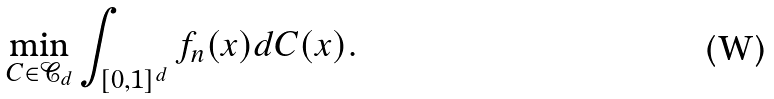Convert formula to latex. <formula><loc_0><loc_0><loc_500><loc_500>\min _ { C \in \mathcal { C } _ { d } } \int _ { [ 0 , 1 ] ^ { d } } f _ { n } ( x ) d C ( x ) .</formula> 